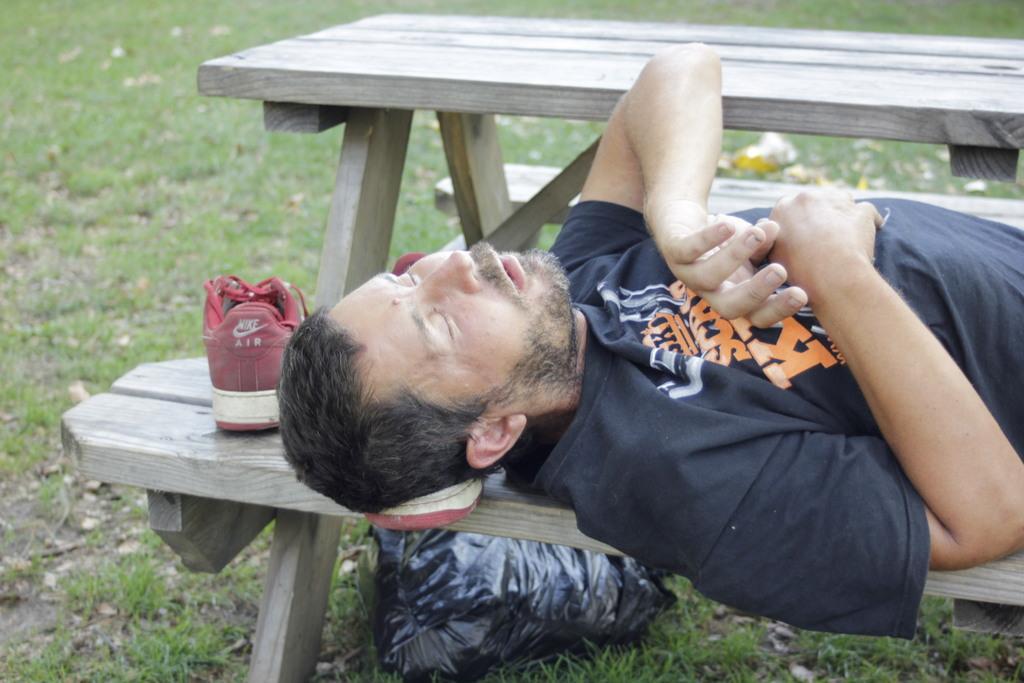Please provide a concise description of this image. In this picture a man is lying on a wooden table with a shoe beside his head. 